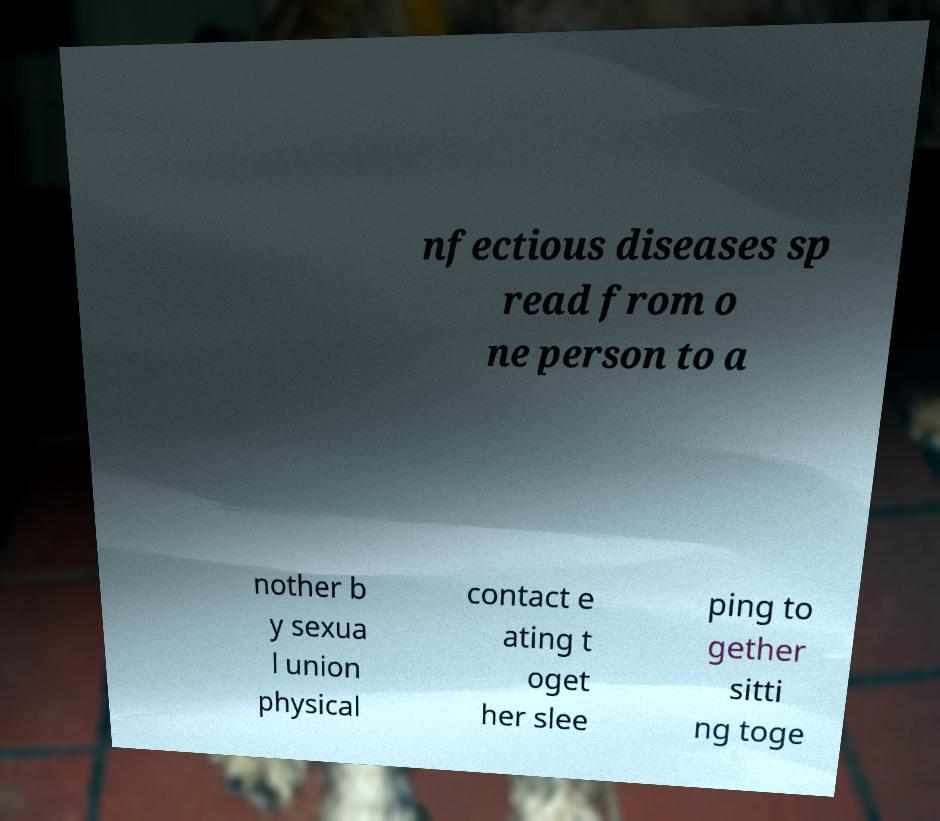Please identify and transcribe the text found in this image. nfectious diseases sp read from o ne person to a nother b y sexua l union physical contact e ating t oget her slee ping to gether sitti ng toge 